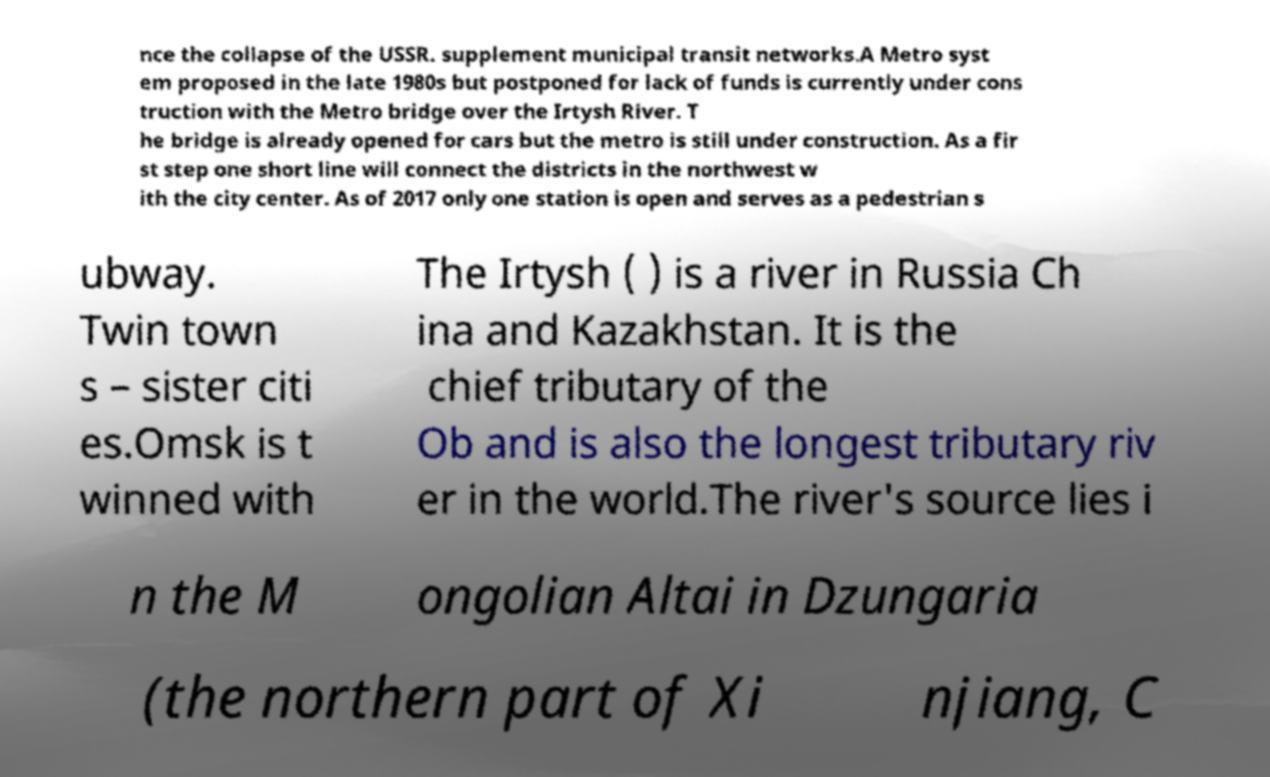For documentation purposes, I need the text within this image transcribed. Could you provide that? nce the collapse of the USSR. supplement municipal transit networks.A Metro syst em proposed in the late 1980s but postponed for lack of funds is currently under cons truction with the Metro bridge over the Irtysh River. T he bridge is already opened for cars but the metro is still under construction. As a fir st step one short line will connect the districts in the northwest w ith the city center. As of 2017 only one station is open and serves as a pedestrian s ubway. Twin town s – sister citi es.Omsk is t winned with The Irtysh ( ) is a river in Russia Ch ina and Kazakhstan. It is the chief tributary of the Ob and is also the longest tributary riv er in the world.The river's source lies i n the M ongolian Altai in Dzungaria (the northern part of Xi njiang, C 